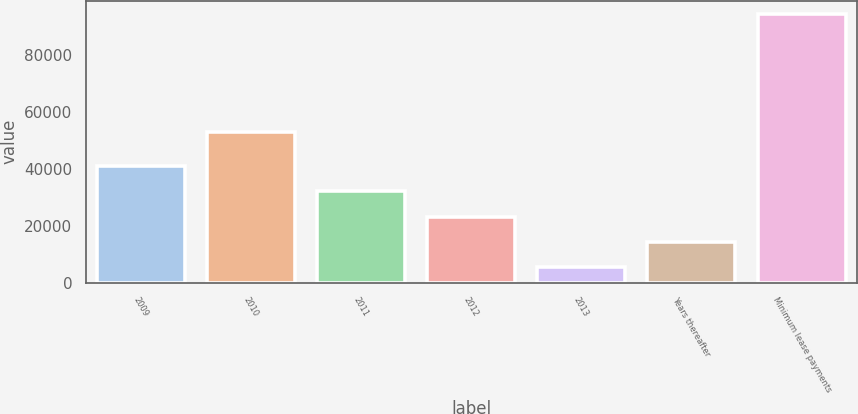Convert chart. <chart><loc_0><loc_0><loc_500><loc_500><bar_chart><fcel>2009<fcel>2010<fcel>2011<fcel>2012<fcel>2013<fcel>Years thereafter<fcel>Minimum lease payments<nl><fcel>41094.6<fcel>53071<fcel>32190.2<fcel>23285.8<fcel>5477<fcel>14381.4<fcel>94521<nl></chart> 